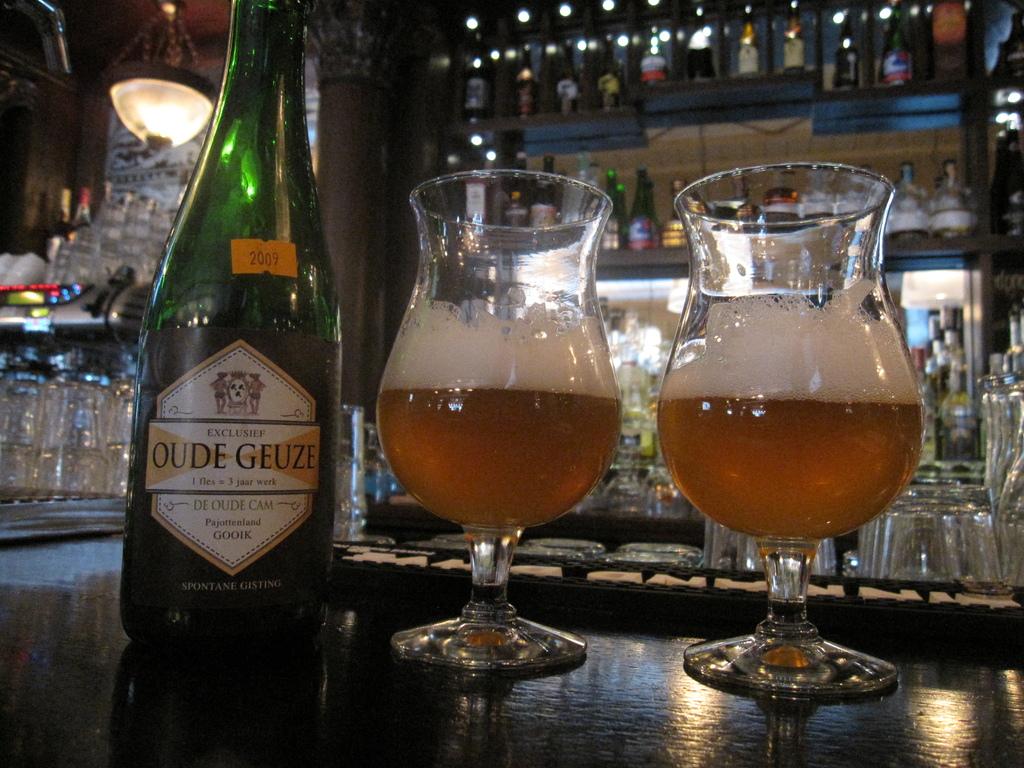What year is labeled on a sticker on this bottle?
Your answer should be very brief. 2009. What brand is on the label?
Ensure brevity in your answer.  Oude geuze. 